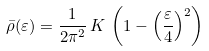<formula> <loc_0><loc_0><loc_500><loc_500>\bar { \rho } ( \varepsilon ) = \frac { 1 } { 2 \pi ^ { 2 } } \, K \, \left ( 1 - \left ( \frac { \varepsilon } { 4 } \right ) ^ { 2 } \right )</formula> 